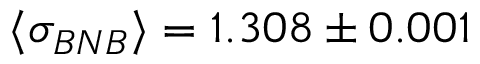Convert formula to latex. <formula><loc_0><loc_0><loc_500><loc_500>\langle \sigma _ { B N B } \rangle = 1 . 3 0 8 \pm 0 . 0 0 1</formula> 